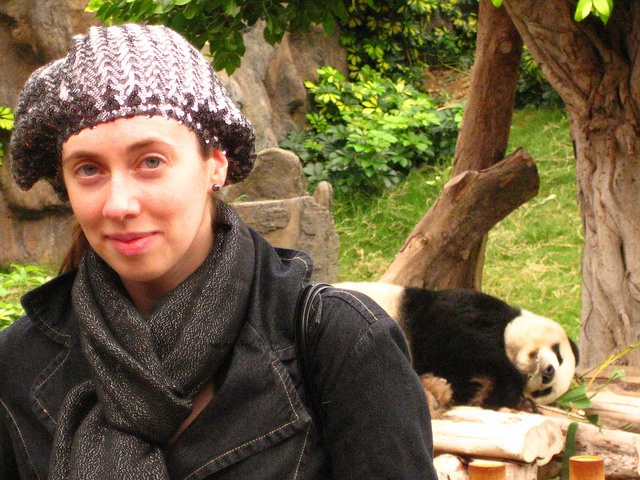Describe the objects in this image and their specific colors. I can see people in maroon, black, gray, and white tones and bear in maroon, black, beige, and tan tones in this image. 